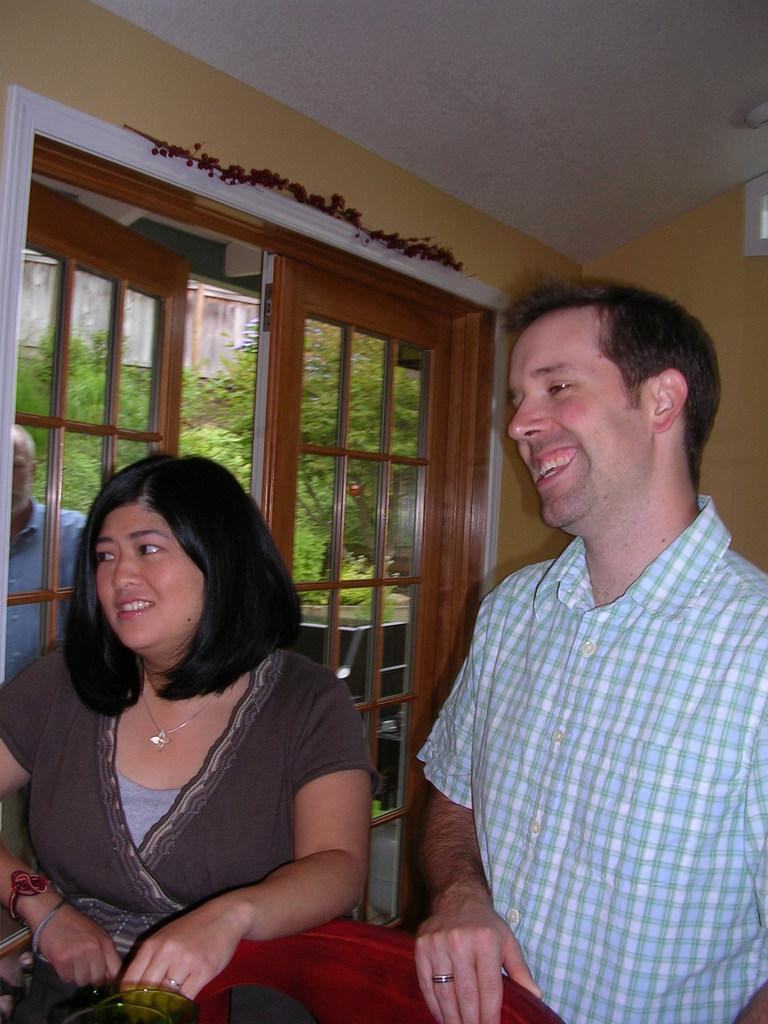How many people are present in the image? There are two people, a man and a woman, present in the image. What is the position of the man and woman in the image? Both the man and woman are standing on the floor. What can be seen in the background of the image? There is a door, a person, trees, and a building in the background of the image. What type of sound can be heard coming from the seashore in the image? There is no reference to a seashore in the image, so it is not possible to determine what, if any, sound might be heard. 